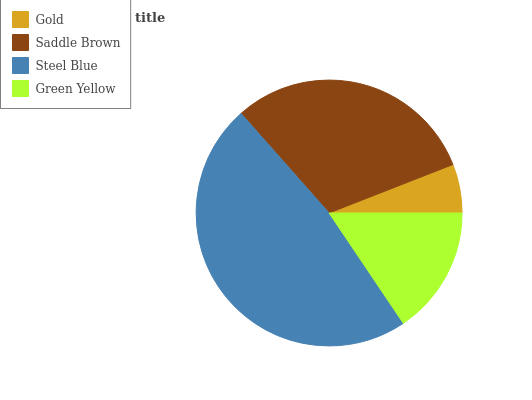Is Gold the minimum?
Answer yes or no. Yes. Is Steel Blue the maximum?
Answer yes or no. Yes. Is Saddle Brown the minimum?
Answer yes or no. No. Is Saddle Brown the maximum?
Answer yes or no. No. Is Saddle Brown greater than Gold?
Answer yes or no. Yes. Is Gold less than Saddle Brown?
Answer yes or no. Yes. Is Gold greater than Saddle Brown?
Answer yes or no. No. Is Saddle Brown less than Gold?
Answer yes or no. No. Is Saddle Brown the high median?
Answer yes or no. Yes. Is Green Yellow the low median?
Answer yes or no. Yes. Is Gold the high median?
Answer yes or no. No. Is Saddle Brown the low median?
Answer yes or no. No. 